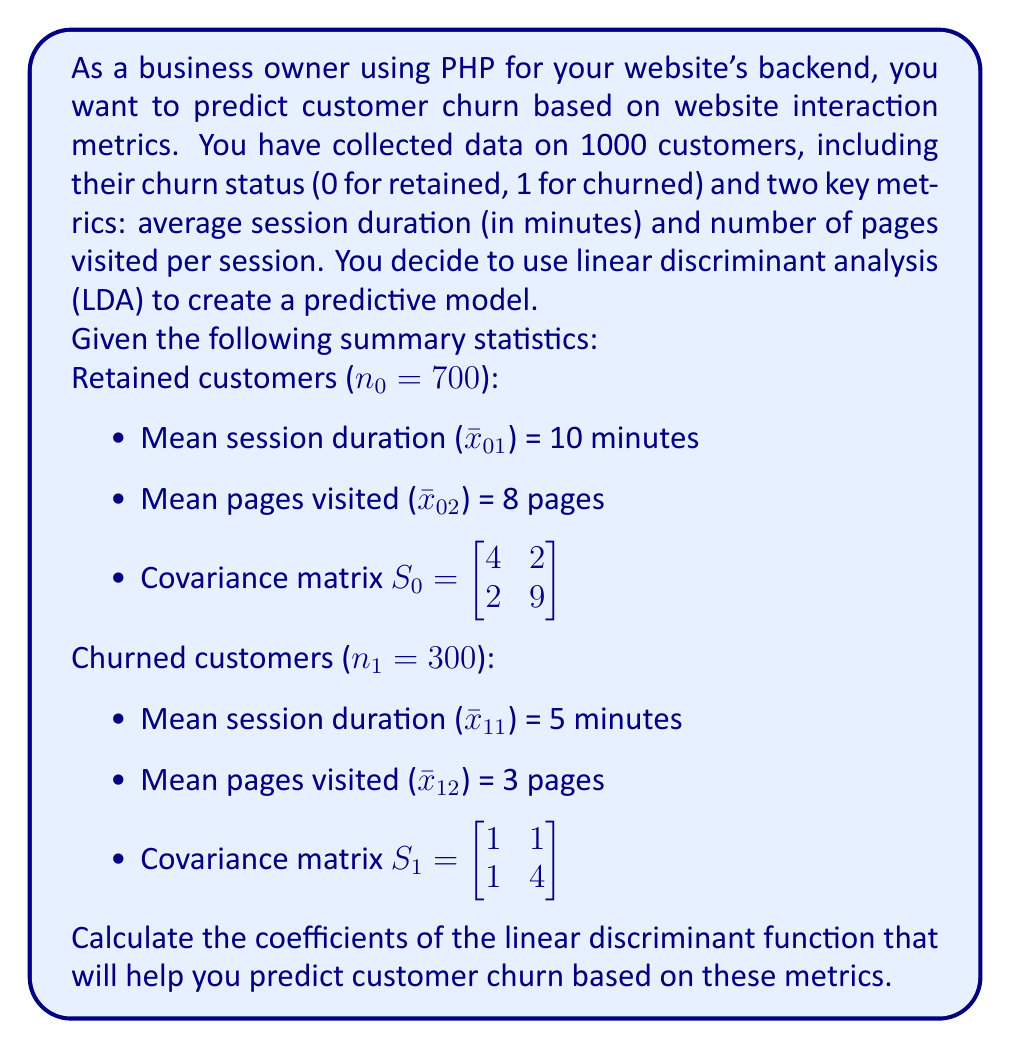Solve this math problem. To solve this problem using linear discriminant analysis (LDA), we'll follow these steps:

1. Calculate the pooled covariance matrix Sₚ:
   $$S_p = \frac{(n_0 - 1)S_0 + (n_1 - 1)S_1}{n_0 + n_1 - 2}$$
   
   $$S_p = \frac{699 \begin{bmatrix} 4 & 2 \\ 2 & 9 \end{bmatrix} + 299 \begin{bmatrix} 1 & 1 \\ 1 & 4 \end{bmatrix}}{998}$$
   
   $$S_p = \begin{bmatrix} 3.1 & 1.7 \\ 1.7 & 7.5 \end{bmatrix}$$

2. Calculate the inverse of the pooled covariance matrix Sₚ⁻¹:
   $$S_p^{-1} = \frac{1}{3.1 \times 7.5 - 1.7 \times 1.7} \begin{bmatrix} 7.5 & -1.7 \\ -1.7 & 3.1 \end{bmatrix}$$
   
   $$S_p^{-1} = \begin{bmatrix} 0.3378 & -0.0766 \\ -0.0766 & 0.1397 \end{bmatrix}$$

3. Calculate the difference between group means:
   $$\bar{x}_0 - \bar{x}_1 = \begin{bmatrix} 10 - 5 \\ 8 - 3 \end{bmatrix} = \begin{bmatrix} 5 \\ 5 \end{bmatrix}$$

4. Calculate the coefficients of the linear discriminant function:
   $$a = S_p^{-1}(\bar{x}_0 - \bar{x}_1)$$
   
   $$a = \begin{bmatrix} 0.3378 & -0.0766 \\ -0.0766 & 0.1397 \end{bmatrix} \begin{bmatrix} 5 \\ 5 \end{bmatrix}$$
   
   $$a = \begin{bmatrix} 1.306 \\ 0.3155 \end{bmatrix}$$

5. The linear discriminant function is:
   $$f(x) = 1.306x_1 + 0.3155x_2$$
   
   Where x₁ is the session duration and x₂ is the number of pages visited.
Answer: $$a = \begin{bmatrix} 1.306 \\ 0.3155 \end{bmatrix}$$ 